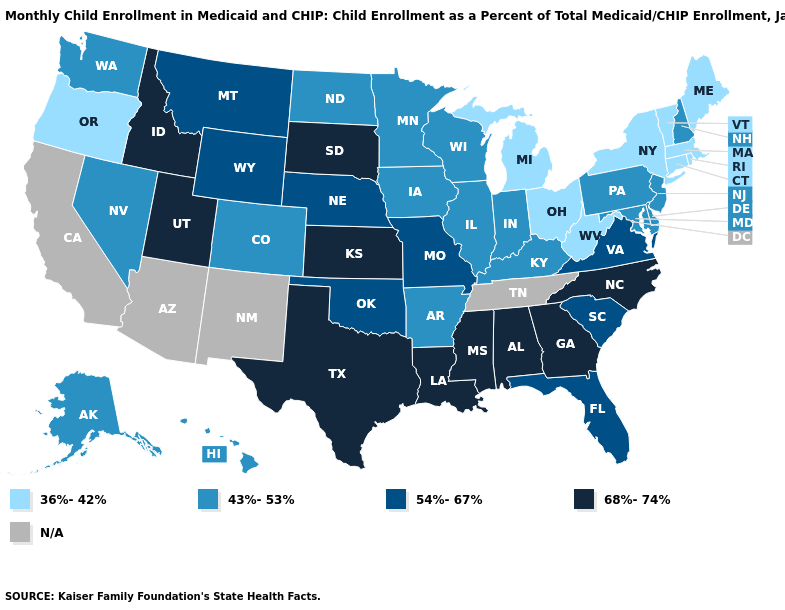Does the map have missing data?
Answer briefly. Yes. What is the highest value in the MidWest ?
Be succinct. 68%-74%. Does the map have missing data?
Keep it brief. Yes. Name the states that have a value in the range 54%-67%?
Quick response, please. Florida, Missouri, Montana, Nebraska, Oklahoma, South Carolina, Virginia, Wyoming. Does the first symbol in the legend represent the smallest category?
Be succinct. Yes. Name the states that have a value in the range 68%-74%?
Concise answer only. Alabama, Georgia, Idaho, Kansas, Louisiana, Mississippi, North Carolina, South Dakota, Texas, Utah. Does Mississippi have the highest value in the USA?
Answer briefly. Yes. Does Florida have the lowest value in the USA?
Quick response, please. No. Does the map have missing data?
Keep it brief. Yes. Does the first symbol in the legend represent the smallest category?
Be succinct. Yes. Name the states that have a value in the range N/A?
Be succinct. Arizona, California, New Mexico, Tennessee. Does the first symbol in the legend represent the smallest category?
Short answer required. Yes. Is the legend a continuous bar?
Give a very brief answer. No. Name the states that have a value in the range N/A?
Concise answer only. Arizona, California, New Mexico, Tennessee. Name the states that have a value in the range 68%-74%?
Concise answer only. Alabama, Georgia, Idaho, Kansas, Louisiana, Mississippi, North Carolina, South Dakota, Texas, Utah. 